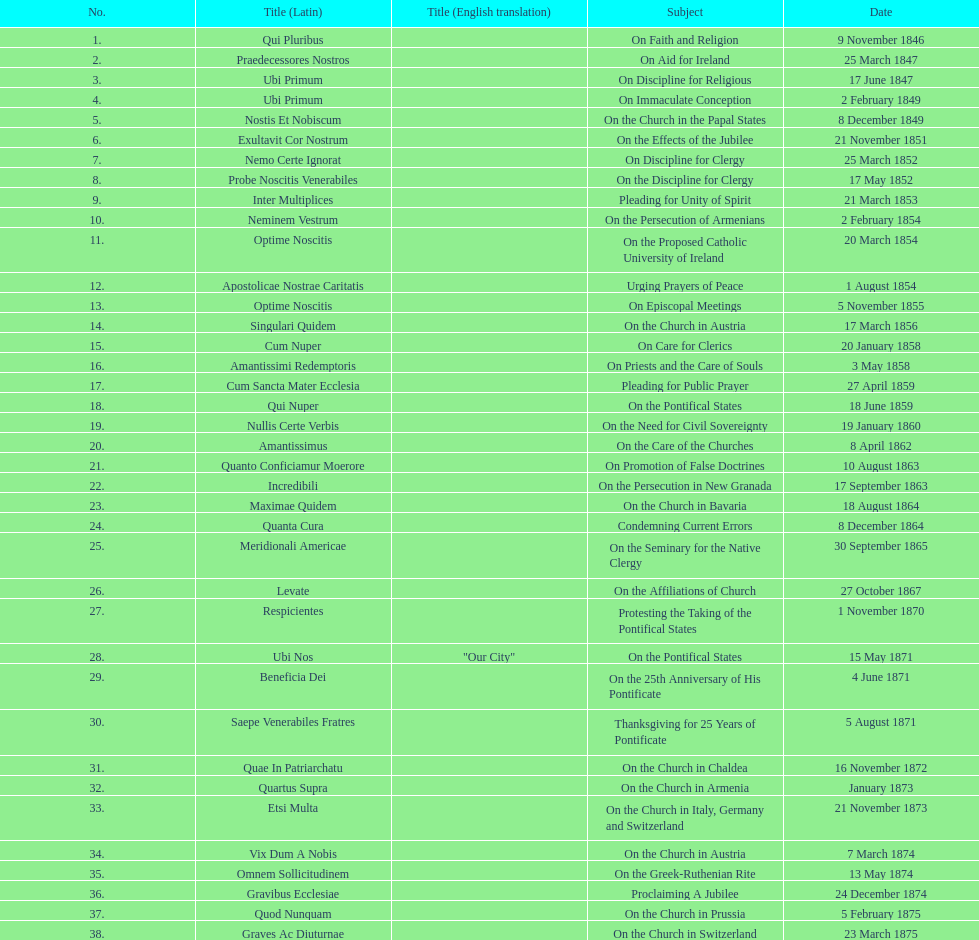Total count of encyclicals regarding churches. 11. 